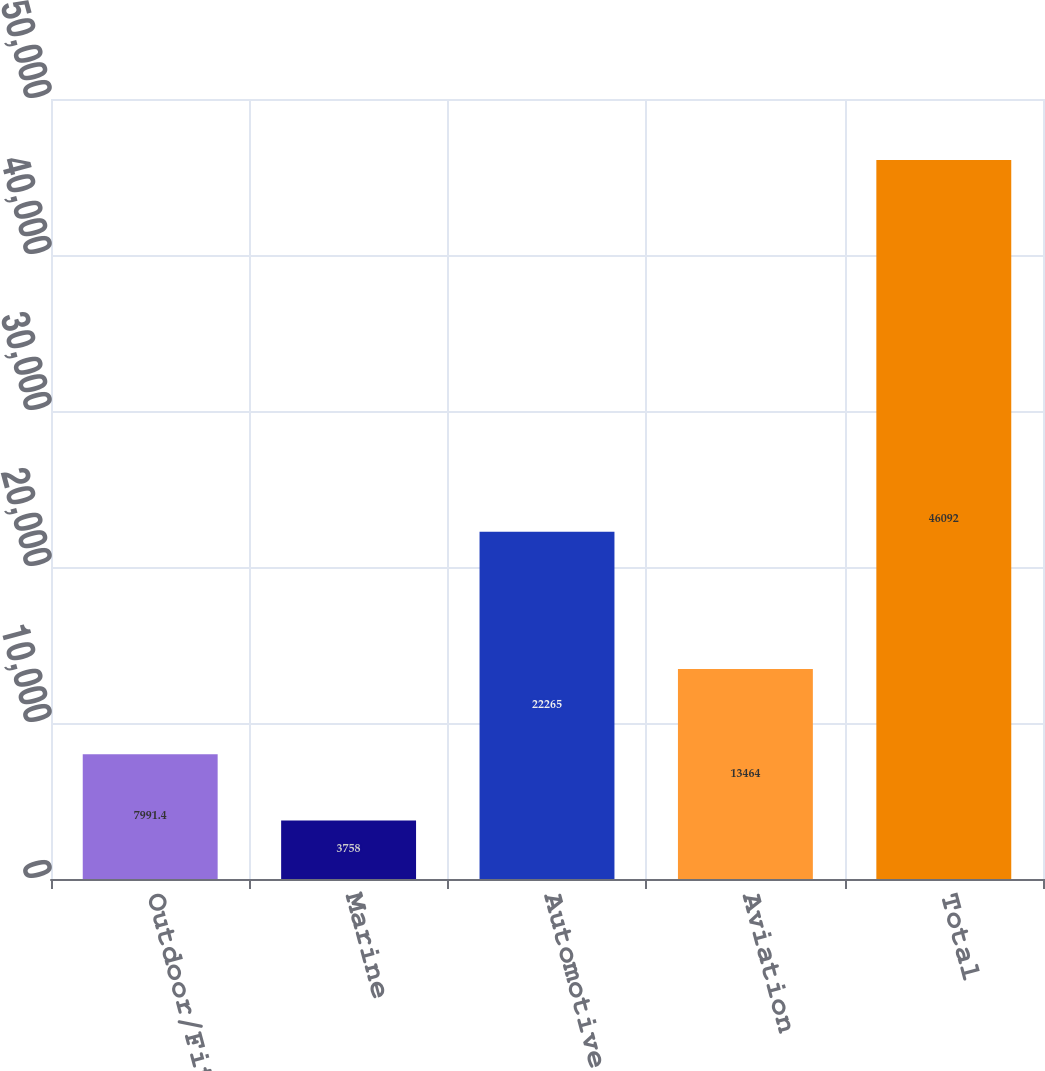<chart> <loc_0><loc_0><loc_500><loc_500><bar_chart><fcel>Outdoor/Fitness<fcel>Marine<fcel>Automotive/Mobile<fcel>Aviation<fcel>Total<nl><fcel>7991.4<fcel>3758<fcel>22265<fcel>13464<fcel>46092<nl></chart> 